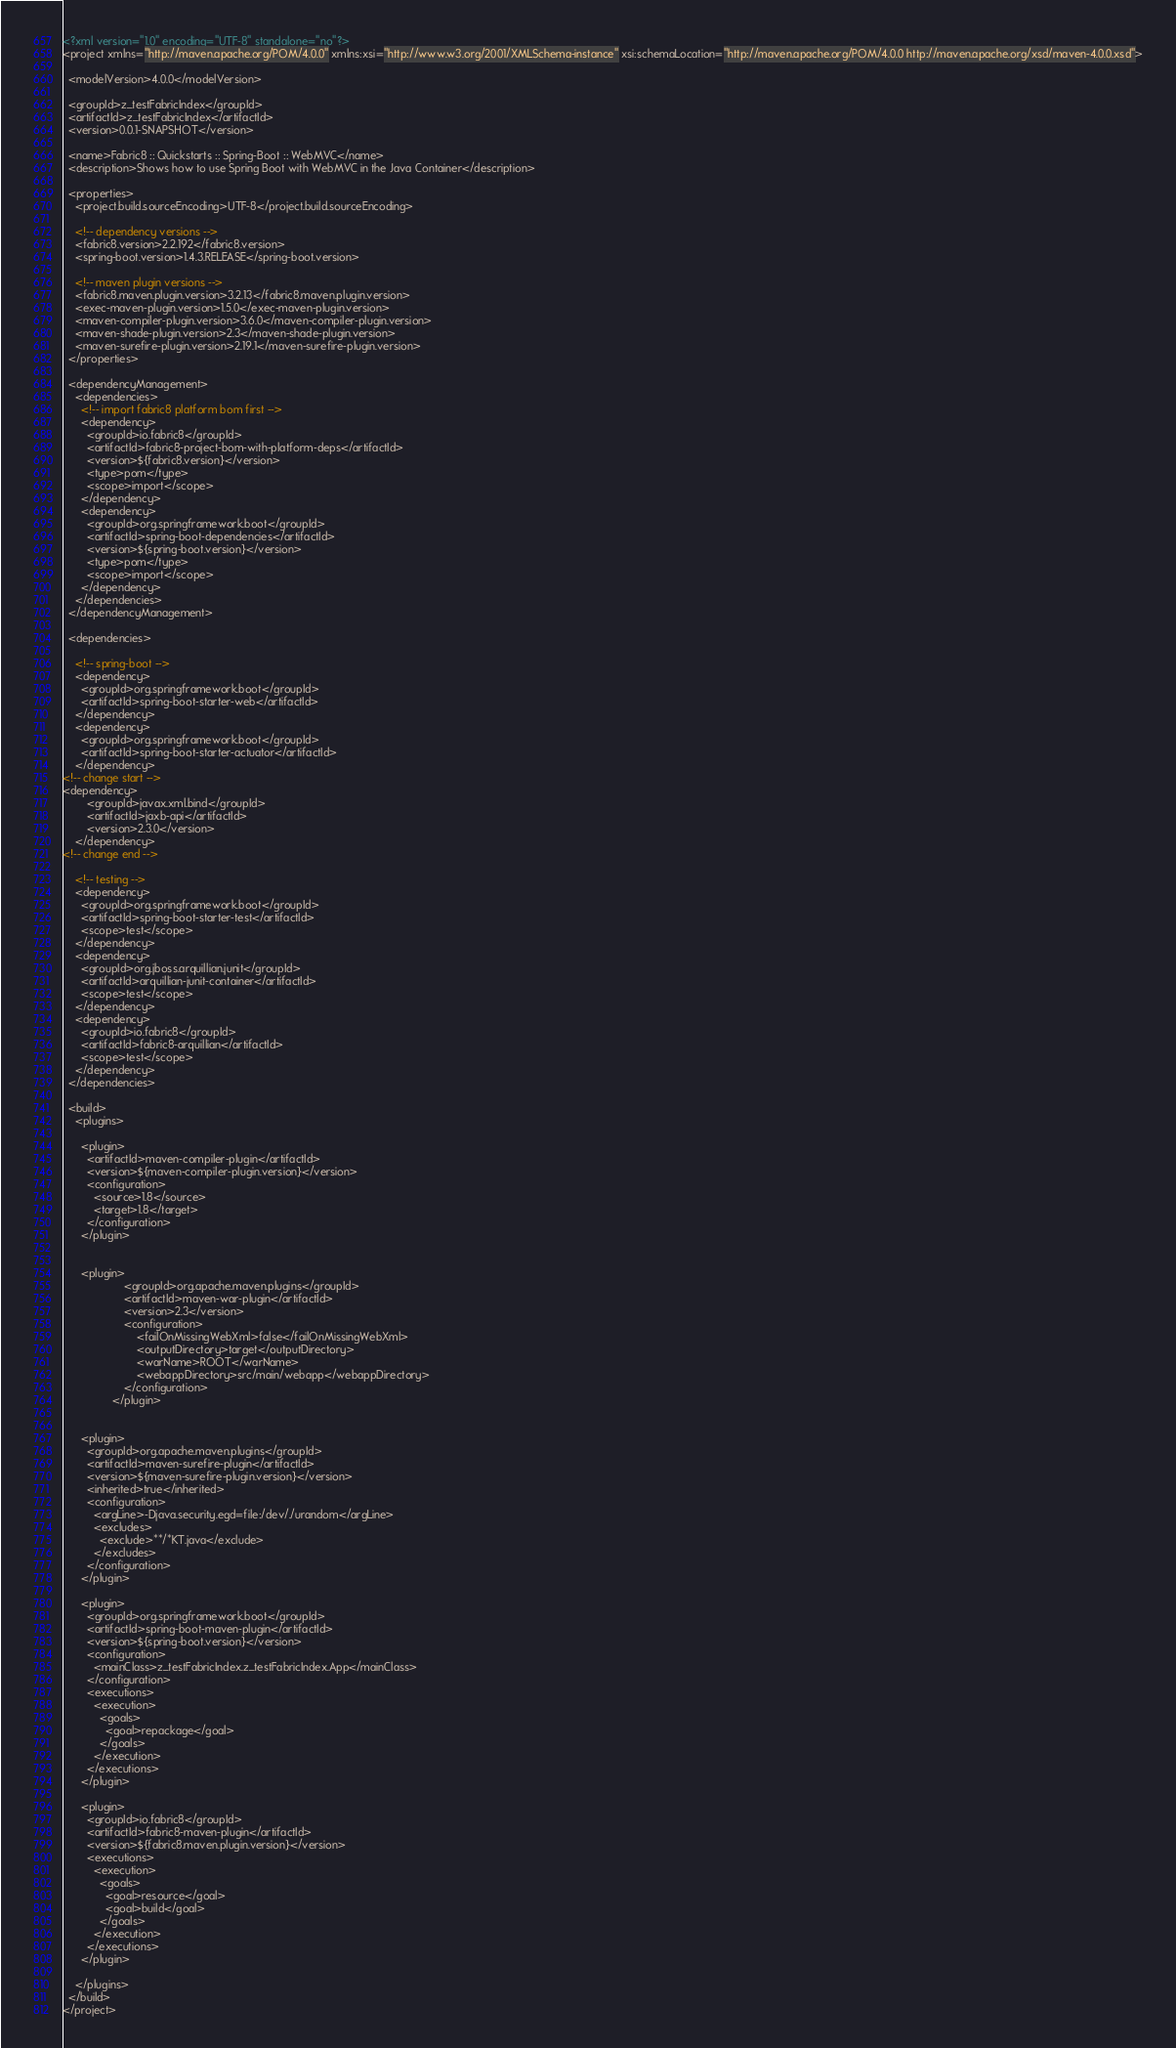<code> <loc_0><loc_0><loc_500><loc_500><_XML_><?xml version="1.0" encoding="UTF-8" standalone="no"?>
<project xmlns="http://maven.apache.org/POM/4.0.0" xmlns:xsi="http://www.w3.org/2001/XMLSchema-instance" xsi:schemaLocation="http://maven.apache.org/POM/4.0.0 http://maven.apache.org/xsd/maven-4.0.0.xsd">

  <modelVersion>4.0.0</modelVersion>

  <groupId>z_testFabricIndex</groupId>
  <artifactId>z_testFabricIndex</artifactId>
  <version>0.0.1-SNAPSHOT</version>

  <name>Fabric8 :: Quickstarts :: Spring-Boot :: WebMVC</name>
  <description>Shows how to use Spring Boot with WebMVC in the Java Container</description>

  <properties>
    <project.build.sourceEncoding>UTF-8</project.build.sourceEncoding>

    <!-- dependency versions -->
    <fabric8.version>2.2.192</fabric8.version>
    <spring-boot.version>1.4.3.RELEASE</spring-boot.version>

    <!-- maven plugin versions -->
    <fabric8.maven.plugin.version>3.2.13</fabric8.maven.plugin.version>
    <exec-maven-plugin.version>1.5.0</exec-maven-plugin.version>
    <maven-compiler-plugin.version>3.6.0</maven-compiler-plugin.version>
    <maven-shade-plugin.version>2.3</maven-shade-plugin.version>
    <maven-surefire-plugin.version>2.19.1</maven-surefire-plugin.version>
  </properties>

  <dependencyManagement>
    <dependencies>
      <!-- import fabric8 platform bom first -->
      <dependency>
        <groupId>io.fabric8</groupId>
        <artifactId>fabric8-project-bom-with-platform-deps</artifactId>
        <version>${fabric8.version}</version>
        <type>pom</type>
        <scope>import</scope>
      </dependency>
      <dependency>
        <groupId>org.springframework.boot</groupId>
        <artifactId>spring-boot-dependencies</artifactId>
        <version>${spring-boot.version}</version>
        <type>pom</type>
        <scope>import</scope>
      </dependency>
    </dependencies>
  </dependencyManagement>

  <dependencies>

    <!-- spring-boot -->
    <dependency>
      <groupId>org.springframework.boot</groupId>
      <artifactId>spring-boot-starter-web</artifactId>
    </dependency>
    <dependency>
      <groupId>org.springframework.boot</groupId>
      <artifactId>spring-boot-starter-actuator</artifactId>
    </dependency>
<!-- change start -->
<dependency>
        <groupId>javax.xml.bind</groupId>
	    <artifactId>jaxb-api</artifactId>
	    <version>2.3.0</version>
	</dependency>
<!-- change end -->

    <!-- testing -->
    <dependency>
      <groupId>org.springframework.boot</groupId>
      <artifactId>spring-boot-starter-test</artifactId>
      <scope>test</scope>
    </dependency>
    <dependency>
      <groupId>org.jboss.arquillian.junit</groupId>
      <artifactId>arquillian-junit-container</artifactId>
      <scope>test</scope>
    </dependency>
    <dependency>
      <groupId>io.fabric8</groupId>
      <artifactId>fabric8-arquillian</artifactId>
      <scope>test</scope>
    </dependency>
  </dependencies>

  <build>
    <plugins>

      <plugin>
        <artifactId>maven-compiler-plugin</artifactId>
        <version>${maven-compiler-plugin.version}</version>
        <configuration>
          <source>1.8</source>
          <target>1.8</target>
        </configuration>
      </plugin>
      
      
      <plugin>
					<groupId>org.apache.maven.plugins</groupId>
					<artifactId>maven-war-plugin</artifactId>
					<version>2.3</version>
					<configuration>
						<failOnMissingWebXml>false</failOnMissingWebXml>
						<outputDirectory>target</outputDirectory>
						<warName>ROOT</warName>
						<webappDirectory>src/main/webapp</webappDirectory>
					</configuration>
				</plugin>
      

      <plugin>
        <groupId>org.apache.maven.plugins</groupId>
        <artifactId>maven-surefire-plugin</artifactId>
        <version>${maven-surefire-plugin.version}</version>
        <inherited>true</inherited>
        <configuration>
          <argLine>-Djava.security.egd=file:/dev/./urandom</argLine>
          <excludes>
            <exclude>**/*KT.java</exclude>
          </excludes>
        </configuration>
      </plugin>

      <plugin>
        <groupId>org.springframework.boot</groupId>
        <artifactId>spring-boot-maven-plugin</artifactId>
        <version>${spring-boot.version}</version>
        <configuration>
          <mainClass>z_testFabricIndex.z_testFabricIndex.App</mainClass>
        </configuration>
        <executions>
          <execution>
            <goals>
              <goal>repackage</goal>
            </goals>
          </execution>
        </executions>
      </plugin>

      <plugin>
        <groupId>io.fabric8</groupId>
        <artifactId>fabric8-maven-plugin</artifactId>
        <version>${fabric8.maven.plugin.version}</version>
        <executions>
          <execution>
            <goals>
              <goal>resource</goal>
              <goal>build</goal>
            </goals>
          </execution>
        </executions>
      </plugin>

    </plugins>
  </build>
</project>
</code> 